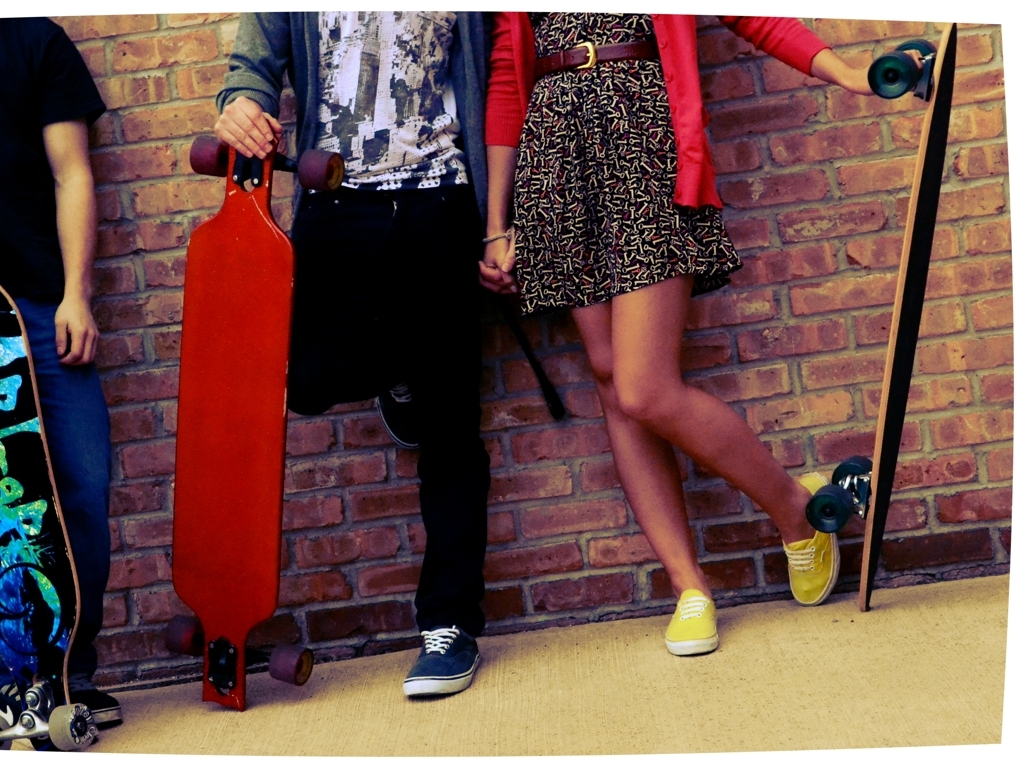What can you infer about the people in this image? From the image, it appears that the people are young adults enjoying leisure time. They're partially visible, with a focus on their lower halves, which features relaxed, stylish streetwear and skateboards, hinting at an interest in skate culture. Their poses and proximity suggest a comfortable and friendly relationship with each other, indicative of a shared hobby or mutual interests in outdoor activities. What does their fashion and accessories say about the current trends? The fashion presented in the image reflects a laid-back, streetwear aesthetic that is often associated with skate culture. The clothing, such as graphic tees, shorts, and casual footwear, alongside skateboards as accessories, indicates a preference for comfort and functionality that aligns with the practical demands of skateboarding. The choice of bright, vibrant colors suggests a youthful vibrancy and a connection to contemporary trends that favor expressive and individualistic styles. 